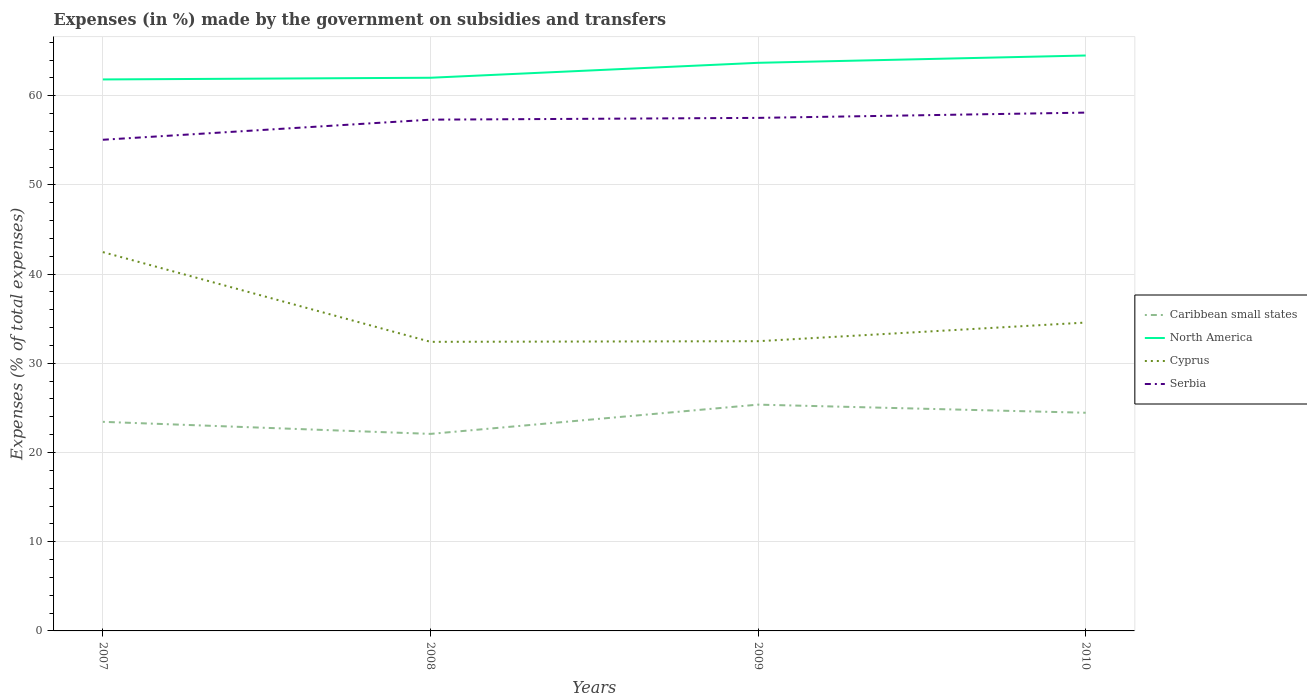How many different coloured lines are there?
Offer a terse response. 4. Does the line corresponding to Serbia intersect with the line corresponding to Caribbean small states?
Ensure brevity in your answer.  No. Across all years, what is the maximum percentage of expenses made by the government on subsidies and transfers in North America?
Your answer should be compact. 61.82. In which year was the percentage of expenses made by the government on subsidies and transfers in Caribbean small states maximum?
Keep it short and to the point. 2008. What is the total percentage of expenses made by the government on subsidies and transfers in North America in the graph?
Offer a terse response. -2.49. What is the difference between the highest and the second highest percentage of expenses made by the government on subsidies and transfers in Cyprus?
Make the answer very short. 10.06. How many years are there in the graph?
Offer a very short reply. 4. What is the difference between two consecutive major ticks on the Y-axis?
Provide a succinct answer. 10. Are the values on the major ticks of Y-axis written in scientific E-notation?
Your answer should be compact. No. Does the graph contain any zero values?
Give a very brief answer. No. Does the graph contain grids?
Keep it short and to the point. Yes. Where does the legend appear in the graph?
Offer a very short reply. Center right. How are the legend labels stacked?
Make the answer very short. Vertical. What is the title of the graph?
Your response must be concise. Expenses (in %) made by the government on subsidies and transfers. What is the label or title of the X-axis?
Make the answer very short. Years. What is the label or title of the Y-axis?
Keep it short and to the point. Expenses (% of total expenses). What is the Expenses (% of total expenses) in Caribbean small states in 2007?
Give a very brief answer. 23.44. What is the Expenses (% of total expenses) in North America in 2007?
Your answer should be compact. 61.82. What is the Expenses (% of total expenses) of Cyprus in 2007?
Provide a succinct answer. 42.47. What is the Expenses (% of total expenses) in Serbia in 2007?
Give a very brief answer. 55.06. What is the Expenses (% of total expenses) of Caribbean small states in 2008?
Offer a very short reply. 22.09. What is the Expenses (% of total expenses) in North America in 2008?
Keep it short and to the point. 62.01. What is the Expenses (% of total expenses) in Cyprus in 2008?
Offer a terse response. 32.41. What is the Expenses (% of total expenses) of Serbia in 2008?
Your response must be concise. 57.32. What is the Expenses (% of total expenses) of Caribbean small states in 2009?
Provide a short and direct response. 25.37. What is the Expenses (% of total expenses) in North America in 2009?
Provide a short and direct response. 63.69. What is the Expenses (% of total expenses) in Cyprus in 2009?
Your answer should be compact. 32.48. What is the Expenses (% of total expenses) in Serbia in 2009?
Provide a short and direct response. 57.52. What is the Expenses (% of total expenses) of Caribbean small states in 2010?
Give a very brief answer. 24.46. What is the Expenses (% of total expenses) of North America in 2010?
Make the answer very short. 64.51. What is the Expenses (% of total expenses) of Cyprus in 2010?
Offer a terse response. 34.57. What is the Expenses (% of total expenses) of Serbia in 2010?
Make the answer very short. 58.11. Across all years, what is the maximum Expenses (% of total expenses) in Caribbean small states?
Provide a short and direct response. 25.37. Across all years, what is the maximum Expenses (% of total expenses) of North America?
Offer a terse response. 64.51. Across all years, what is the maximum Expenses (% of total expenses) of Cyprus?
Your answer should be compact. 42.47. Across all years, what is the maximum Expenses (% of total expenses) of Serbia?
Offer a very short reply. 58.11. Across all years, what is the minimum Expenses (% of total expenses) in Caribbean small states?
Offer a terse response. 22.09. Across all years, what is the minimum Expenses (% of total expenses) in North America?
Ensure brevity in your answer.  61.82. Across all years, what is the minimum Expenses (% of total expenses) in Cyprus?
Offer a terse response. 32.41. Across all years, what is the minimum Expenses (% of total expenses) in Serbia?
Offer a very short reply. 55.06. What is the total Expenses (% of total expenses) of Caribbean small states in the graph?
Give a very brief answer. 95.36. What is the total Expenses (% of total expenses) of North America in the graph?
Provide a succinct answer. 252.04. What is the total Expenses (% of total expenses) in Cyprus in the graph?
Your response must be concise. 141.93. What is the total Expenses (% of total expenses) of Serbia in the graph?
Ensure brevity in your answer.  228. What is the difference between the Expenses (% of total expenses) of Caribbean small states in 2007 and that in 2008?
Provide a succinct answer. 1.35. What is the difference between the Expenses (% of total expenses) in North America in 2007 and that in 2008?
Your response must be concise. -0.19. What is the difference between the Expenses (% of total expenses) in Cyprus in 2007 and that in 2008?
Make the answer very short. 10.06. What is the difference between the Expenses (% of total expenses) in Serbia in 2007 and that in 2008?
Provide a short and direct response. -2.25. What is the difference between the Expenses (% of total expenses) in Caribbean small states in 2007 and that in 2009?
Offer a very short reply. -1.93. What is the difference between the Expenses (% of total expenses) of North America in 2007 and that in 2009?
Your answer should be compact. -1.87. What is the difference between the Expenses (% of total expenses) of Cyprus in 2007 and that in 2009?
Your response must be concise. 9.99. What is the difference between the Expenses (% of total expenses) of Serbia in 2007 and that in 2009?
Provide a short and direct response. -2.45. What is the difference between the Expenses (% of total expenses) of Caribbean small states in 2007 and that in 2010?
Provide a succinct answer. -1.02. What is the difference between the Expenses (% of total expenses) of North America in 2007 and that in 2010?
Offer a terse response. -2.68. What is the difference between the Expenses (% of total expenses) in Cyprus in 2007 and that in 2010?
Provide a short and direct response. 7.9. What is the difference between the Expenses (% of total expenses) of Serbia in 2007 and that in 2010?
Keep it short and to the point. -3.04. What is the difference between the Expenses (% of total expenses) of Caribbean small states in 2008 and that in 2009?
Provide a succinct answer. -3.28. What is the difference between the Expenses (% of total expenses) of North America in 2008 and that in 2009?
Offer a very short reply. -1.67. What is the difference between the Expenses (% of total expenses) of Cyprus in 2008 and that in 2009?
Your answer should be compact. -0.07. What is the difference between the Expenses (% of total expenses) of Serbia in 2008 and that in 2009?
Offer a terse response. -0.2. What is the difference between the Expenses (% of total expenses) of Caribbean small states in 2008 and that in 2010?
Keep it short and to the point. -2.37. What is the difference between the Expenses (% of total expenses) of North America in 2008 and that in 2010?
Offer a terse response. -2.49. What is the difference between the Expenses (% of total expenses) of Cyprus in 2008 and that in 2010?
Give a very brief answer. -2.16. What is the difference between the Expenses (% of total expenses) of Serbia in 2008 and that in 2010?
Your answer should be compact. -0.79. What is the difference between the Expenses (% of total expenses) of Caribbean small states in 2009 and that in 2010?
Provide a short and direct response. 0.91. What is the difference between the Expenses (% of total expenses) in North America in 2009 and that in 2010?
Provide a short and direct response. -0.82. What is the difference between the Expenses (% of total expenses) of Cyprus in 2009 and that in 2010?
Provide a short and direct response. -2.09. What is the difference between the Expenses (% of total expenses) in Serbia in 2009 and that in 2010?
Offer a terse response. -0.59. What is the difference between the Expenses (% of total expenses) in Caribbean small states in 2007 and the Expenses (% of total expenses) in North America in 2008?
Keep it short and to the point. -38.57. What is the difference between the Expenses (% of total expenses) in Caribbean small states in 2007 and the Expenses (% of total expenses) in Cyprus in 2008?
Keep it short and to the point. -8.97. What is the difference between the Expenses (% of total expenses) in Caribbean small states in 2007 and the Expenses (% of total expenses) in Serbia in 2008?
Provide a short and direct response. -33.88. What is the difference between the Expenses (% of total expenses) in North America in 2007 and the Expenses (% of total expenses) in Cyprus in 2008?
Ensure brevity in your answer.  29.42. What is the difference between the Expenses (% of total expenses) of North America in 2007 and the Expenses (% of total expenses) of Serbia in 2008?
Provide a succinct answer. 4.51. What is the difference between the Expenses (% of total expenses) of Cyprus in 2007 and the Expenses (% of total expenses) of Serbia in 2008?
Your answer should be compact. -14.85. What is the difference between the Expenses (% of total expenses) of Caribbean small states in 2007 and the Expenses (% of total expenses) of North America in 2009?
Ensure brevity in your answer.  -40.25. What is the difference between the Expenses (% of total expenses) in Caribbean small states in 2007 and the Expenses (% of total expenses) in Cyprus in 2009?
Offer a very short reply. -9.04. What is the difference between the Expenses (% of total expenses) of Caribbean small states in 2007 and the Expenses (% of total expenses) of Serbia in 2009?
Your response must be concise. -34.08. What is the difference between the Expenses (% of total expenses) of North America in 2007 and the Expenses (% of total expenses) of Cyprus in 2009?
Provide a short and direct response. 29.34. What is the difference between the Expenses (% of total expenses) in North America in 2007 and the Expenses (% of total expenses) in Serbia in 2009?
Ensure brevity in your answer.  4.31. What is the difference between the Expenses (% of total expenses) of Cyprus in 2007 and the Expenses (% of total expenses) of Serbia in 2009?
Ensure brevity in your answer.  -15.05. What is the difference between the Expenses (% of total expenses) in Caribbean small states in 2007 and the Expenses (% of total expenses) in North America in 2010?
Offer a very short reply. -41.07. What is the difference between the Expenses (% of total expenses) of Caribbean small states in 2007 and the Expenses (% of total expenses) of Cyprus in 2010?
Your response must be concise. -11.13. What is the difference between the Expenses (% of total expenses) of Caribbean small states in 2007 and the Expenses (% of total expenses) of Serbia in 2010?
Give a very brief answer. -34.67. What is the difference between the Expenses (% of total expenses) in North America in 2007 and the Expenses (% of total expenses) in Cyprus in 2010?
Offer a very short reply. 27.25. What is the difference between the Expenses (% of total expenses) in North America in 2007 and the Expenses (% of total expenses) in Serbia in 2010?
Your answer should be compact. 3.72. What is the difference between the Expenses (% of total expenses) of Cyprus in 2007 and the Expenses (% of total expenses) of Serbia in 2010?
Your answer should be very brief. -15.64. What is the difference between the Expenses (% of total expenses) of Caribbean small states in 2008 and the Expenses (% of total expenses) of North America in 2009?
Make the answer very short. -41.6. What is the difference between the Expenses (% of total expenses) of Caribbean small states in 2008 and the Expenses (% of total expenses) of Cyprus in 2009?
Offer a very short reply. -10.39. What is the difference between the Expenses (% of total expenses) of Caribbean small states in 2008 and the Expenses (% of total expenses) of Serbia in 2009?
Your answer should be very brief. -35.43. What is the difference between the Expenses (% of total expenses) in North America in 2008 and the Expenses (% of total expenses) in Cyprus in 2009?
Ensure brevity in your answer.  29.53. What is the difference between the Expenses (% of total expenses) of North America in 2008 and the Expenses (% of total expenses) of Serbia in 2009?
Ensure brevity in your answer.  4.5. What is the difference between the Expenses (% of total expenses) of Cyprus in 2008 and the Expenses (% of total expenses) of Serbia in 2009?
Your answer should be compact. -25.11. What is the difference between the Expenses (% of total expenses) in Caribbean small states in 2008 and the Expenses (% of total expenses) in North America in 2010?
Your answer should be compact. -42.42. What is the difference between the Expenses (% of total expenses) of Caribbean small states in 2008 and the Expenses (% of total expenses) of Cyprus in 2010?
Ensure brevity in your answer.  -12.48. What is the difference between the Expenses (% of total expenses) of Caribbean small states in 2008 and the Expenses (% of total expenses) of Serbia in 2010?
Provide a succinct answer. -36.02. What is the difference between the Expenses (% of total expenses) of North America in 2008 and the Expenses (% of total expenses) of Cyprus in 2010?
Ensure brevity in your answer.  27.45. What is the difference between the Expenses (% of total expenses) of North America in 2008 and the Expenses (% of total expenses) of Serbia in 2010?
Offer a terse response. 3.91. What is the difference between the Expenses (% of total expenses) of Cyprus in 2008 and the Expenses (% of total expenses) of Serbia in 2010?
Your answer should be compact. -25.7. What is the difference between the Expenses (% of total expenses) of Caribbean small states in 2009 and the Expenses (% of total expenses) of North America in 2010?
Make the answer very short. -39.14. What is the difference between the Expenses (% of total expenses) in Caribbean small states in 2009 and the Expenses (% of total expenses) in Cyprus in 2010?
Make the answer very short. -9.2. What is the difference between the Expenses (% of total expenses) in Caribbean small states in 2009 and the Expenses (% of total expenses) in Serbia in 2010?
Your response must be concise. -32.74. What is the difference between the Expenses (% of total expenses) in North America in 2009 and the Expenses (% of total expenses) in Cyprus in 2010?
Offer a very short reply. 29.12. What is the difference between the Expenses (% of total expenses) of North America in 2009 and the Expenses (% of total expenses) of Serbia in 2010?
Make the answer very short. 5.58. What is the difference between the Expenses (% of total expenses) in Cyprus in 2009 and the Expenses (% of total expenses) in Serbia in 2010?
Provide a short and direct response. -25.63. What is the average Expenses (% of total expenses) in Caribbean small states per year?
Make the answer very short. 23.84. What is the average Expenses (% of total expenses) of North America per year?
Your answer should be very brief. 63.01. What is the average Expenses (% of total expenses) in Cyprus per year?
Ensure brevity in your answer.  35.48. What is the average Expenses (% of total expenses) in Serbia per year?
Ensure brevity in your answer.  57. In the year 2007, what is the difference between the Expenses (% of total expenses) in Caribbean small states and Expenses (% of total expenses) in North America?
Give a very brief answer. -38.38. In the year 2007, what is the difference between the Expenses (% of total expenses) of Caribbean small states and Expenses (% of total expenses) of Cyprus?
Offer a terse response. -19.03. In the year 2007, what is the difference between the Expenses (% of total expenses) in Caribbean small states and Expenses (% of total expenses) in Serbia?
Provide a short and direct response. -31.62. In the year 2007, what is the difference between the Expenses (% of total expenses) in North America and Expenses (% of total expenses) in Cyprus?
Make the answer very short. 19.36. In the year 2007, what is the difference between the Expenses (% of total expenses) of North America and Expenses (% of total expenses) of Serbia?
Offer a very short reply. 6.76. In the year 2007, what is the difference between the Expenses (% of total expenses) in Cyprus and Expenses (% of total expenses) in Serbia?
Ensure brevity in your answer.  -12.59. In the year 2008, what is the difference between the Expenses (% of total expenses) in Caribbean small states and Expenses (% of total expenses) in North America?
Keep it short and to the point. -39.93. In the year 2008, what is the difference between the Expenses (% of total expenses) of Caribbean small states and Expenses (% of total expenses) of Cyprus?
Your answer should be compact. -10.32. In the year 2008, what is the difference between the Expenses (% of total expenses) of Caribbean small states and Expenses (% of total expenses) of Serbia?
Offer a terse response. -35.23. In the year 2008, what is the difference between the Expenses (% of total expenses) in North America and Expenses (% of total expenses) in Cyprus?
Offer a terse response. 29.61. In the year 2008, what is the difference between the Expenses (% of total expenses) of North America and Expenses (% of total expenses) of Serbia?
Offer a very short reply. 4.7. In the year 2008, what is the difference between the Expenses (% of total expenses) in Cyprus and Expenses (% of total expenses) in Serbia?
Your response must be concise. -24.91. In the year 2009, what is the difference between the Expenses (% of total expenses) in Caribbean small states and Expenses (% of total expenses) in North America?
Give a very brief answer. -38.32. In the year 2009, what is the difference between the Expenses (% of total expenses) in Caribbean small states and Expenses (% of total expenses) in Cyprus?
Offer a very short reply. -7.11. In the year 2009, what is the difference between the Expenses (% of total expenses) of Caribbean small states and Expenses (% of total expenses) of Serbia?
Give a very brief answer. -32.15. In the year 2009, what is the difference between the Expenses (% of total expenses) of North America and Expenses (% of total expenses) of Cyprus?
Offer a very short reply. 31.21. In the year 2009, what is the difference between the Expenses (% of total expenses) in North America and Expenses (% of total expenses) in Serbia?
Provide a succinct answer. 6.17. In the year 2009, what is the difference between the Expenses (% of total expenses) in Cyprus and Expenses (% of total expenses) in Serbia?
Make the answer very short. -25.04. In the year 2010, what is the difference between the Expenses (% of total expenses) of Caribbean small states and Expenses (% of total expenses) of North America?
Give a very brief answer. -40.05. In the year 2010, what is the difference between the Expenses (% of total expenses) in Caribbean small states and Expenses (% of total expenses) in Cyprus?
Make the answer very short. -10.11. In the year 2010, what is the difference between the Expenses (% of total expenses) of Caribbean small states and Expenses (% of total expenses) of Serbia?
Make the answer very short. -33.65. In the year 2010, what is the difference between the Expenses (% of total expenses) in North America and Expenses (% of total expenses) in Cyprus?
Your answer should be compact. 29.94. In the year 2010, what is the difference between the Expenses (% of total expenses) in North America and Expenses (% of total expenses) in Serbia?
Offer a terse response. 6.4. In the year 2010, what is the difference between the Expenses (% of total expenses) in Cyprus and Expenses (% of total expenses) in Serbia?
Provide a succinct answer. -23.54. What is the ratio of the Expenses (% of total expenses) in Caribbean small states in 2007 to that in 2008?
Offer a very short reply. 1.06. What is the ratio of the Expenses (% of total expenses) of North America in 2007 to that in 2008?
Make the answer very short. 1. What is the ratio of the Expenses (% of total expenses) of Cyprus in 2007 to that in 2008?
Offer a terse response. 1.31. What is the ratio of the Expenses (% of total expenses) of Serbia in 2007 to that in 2008?
Give a very brief answer. 0.96. What is the ratio of the Expenses (% of total expenses) in Caribbean small states in 2007 to that in 2009?
Offer a terse response. 0.92. What is the ratio of the Expenses (% of total expenses) of North America in 2007 to that in 2009?
Provide a succinct answer. 0.97. What is the ratio of the Expenses (% of total expenses) of Cyprus in 2007 to that in 2009?
Give a very brief answer. 1.31. What is the ratio of the Expenses (% of total expenses) of Serbia in 2007 to that in 2009?
Your answer should be very brief. 0.96. What is the ratio of the Expenses (% of total expenses) in Caribbean small states in 2007 to that in 2010?
Your answer should be very brief. 0.96. What is the ratio of the Expenses (% of total expenses) in North America in 2007 to that in 2010?
Make the answer very short. 0.96. What is the ratio of the Expenses (% of total expenses) in Cyprus in 2007 to that in 2010?
Offer a very short reply. 1.23. What is the ratio of the Expenses (% of total expenses) in Serbia in 2007 to that in 2010?
Keep it short and to the point. 0.95. What is the ratio of the Expenses (% of total expenses) in Caribbean small states in 2008 to that in 2009?
Provide a succinct answer. 0.87. What is the ratio of the Expenses (% of total expenses) in North America in 2008 to that in 2009?
Keep it short and to the point. 0.97. What is the ratio of the Expenses (% of total expenses) of Cyprus in 2008 to that in 2009?
Your answer should be compact. 1. What is the ratio of the Expenses (% of total expenses) in Caribbean small states in 2008 to that in 2010?
Your response must be concise. 0.9. What is the ratio of the Expenses (% of total expenses) in North America in 2008 to that in 2010?
Keep it short and to the point. 0.96. What is the ratio of the Expenses (% of total expenses) in Serbia in 2008 to that in 2010?
Keep it short and to the point. 0.99. What is the ratio of the Expenses (% of total expenses) of Caribbean small states in 2009 to that in 2010?
Provide a short and direct response. 1.04. What is the ratio of the Expenses (% of total expenses) of North America in 2009 to that in 2010?
Ensure brevity in your answer.  0.99. What is the ratio of the Expenses (% of total expenses) in Cyprus in 2009 to that in 2010?
Your answer should be very brief. 0.94. What is the ratio of the Expenses (% of total expenses) in Serbia in 2009 to that in 2010?
Provide a short and direct response. 0.99. What is the difference between the highest and the second highest Expenses (% of total expenses) of Caribbean small states?
Keep it short and to the point. 0.91. What is the difference between the highest and the second highest Expenses (% of total expenses) of North America?
Provide a short and direct response. 0.82. What is the difference between the highest and the second highest Expenses (% of total expenses) of Cyprus?
Provide a short and direct response. 7.9. What is the difference between the highest and the second highest Expenses (% of total expenses) of Serbia?
Offer a very short reply. 0.59. What is the difference between the highest and the lowest Expenses (% of total expenses) in Caribbean small states?
Your answer should be compact. 3.28. What is the difference between the highest and the lowest Expenses (% of total expenses) in North America?
Provide a short and direct response. 2.68. What is the difference between the highest and the lowest Expenses (% of total expenses) in Cyprus?
Your answer should be very brief. 10.06. What is the difference between the highest and the lowest Expenses (% of total expenses) of Serbia?
Provide a succinct answer. 3.04. 